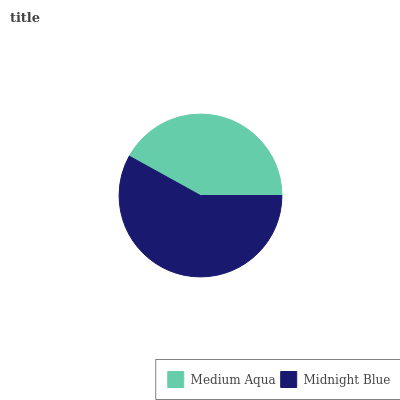Is Medium Aqua the minimum?
Answer yes or no. Yes. Is Midnight Blue the maximum?
Answer yes or no. Yes. Is Midnight Blue the minimum?
Answer yes or no. No. Is Midnight Blue greater than Medium Aqua?
Answer yes or no. Yes. Is Medium Aqua less than Midnight Blue?
Answer yes or no. Yes. Is Medium Aqua greater than Midnight Blue?
Answer yes or no. No. Is Midnight Blue less than Medium Aqua?
Answer yes or no. No. Is Midnight Blue the high median?
Answer yes or no. Yes. Is Medium Aqua the low median?
Answer yes or no. Yes. Is Medium Aqua the high median?
Answer yes or no. No. Is Midnight Blue the low median?
Answer yes or no. No. 